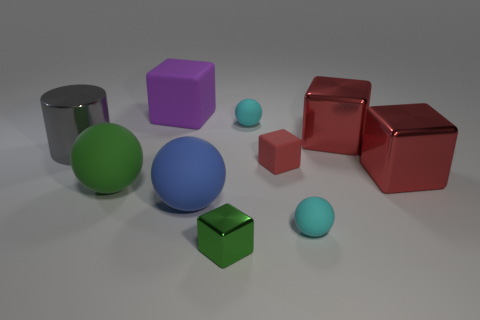The other thing that is the same color as the tiny metal object is what size?
Offer a very short reply. Large. Are there any large things that have the same color as the small rubber cube?
Offer a terse response. Yes. What number of objects are either large cubes in front of the gray cylinder or large yellow cylinders?
Make the answer very short. 1. What number of big blue objects are made of the same material as the small green block?
Offer a very short reply. 0. The matte thing that is the same color as the tiny shiny thing is what shape?
Offer a terse response. Sphere. Is the number of rubber objects that are to the left of the purple thing the same as the number of matte blocks?
Provide a short and direct response. No. There is a gray shiny cylinder that is on the left side of the big blue ball; what size is it?
Provide a short and direct response. Large. How many tiny things are either gray rubber cylinders or purple cubes?
Keep it short and to the point. 0. What is the color of the other large rubber object that is the same shape as the red matte object?
Provide a short and direct response. Purple. Do the green matte sphere and the blue rubber sphere have the same size?
Give a very brief answer. Yes. 